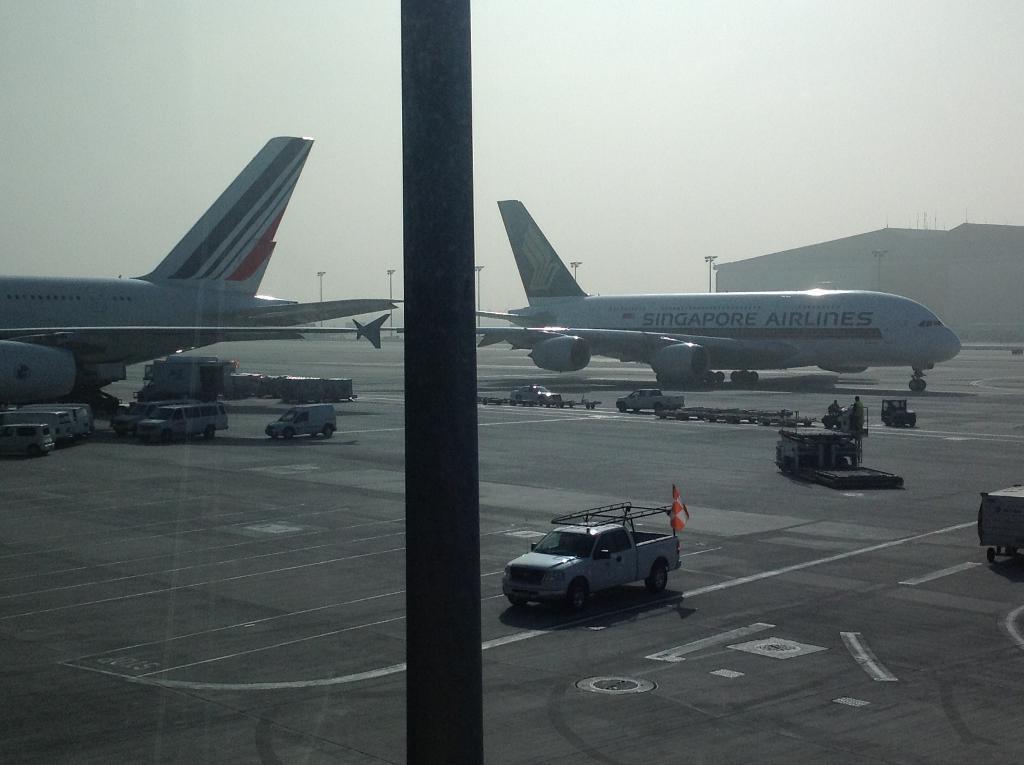How would you summarize this image in a sentence or two? In this picture there are aeroplanes on the right and left side of the image and there are vans in the center of the image and there are poles in the background area of the image. 